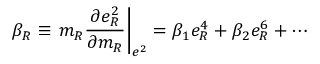Convert formula to latex. <formula><loc_0><loc_0><loc_500><loc_500>\beta _ { R } \equiv m _ { R } \frac { \partial e _ { R } ^ { 2 } } { \partial m _ { R } } \right | _ { e ^ { 2 } } = \beta _ { 1 } e _ { R } ^ { 4 } + \beta _ { 2 } e _ { R } ^ { 6 } + \cdots</formula> 